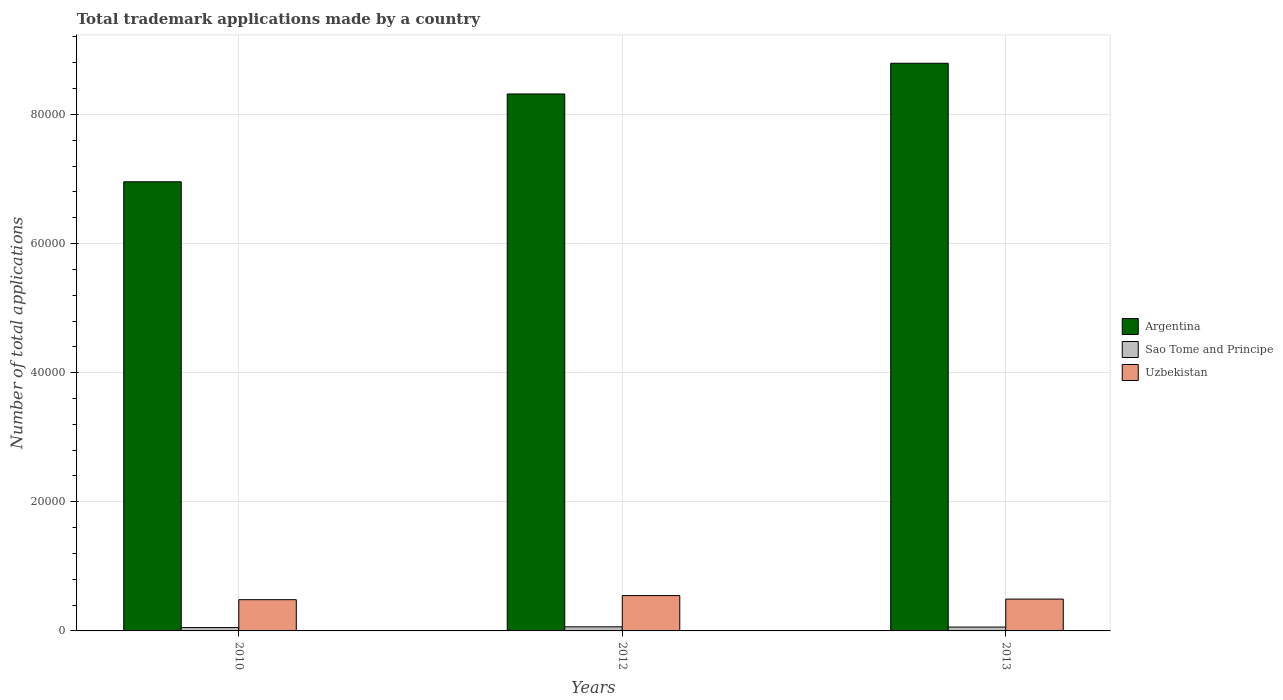How many groups of bars are there?
Make the answer very short. 3. Are the number of bars per tick equal to the number of legend labels?
Provide a succinct answer. Yes. Are the number of bars on each tick of the X-axis equal?
Your answer should be very brief. Yes. How many bars are there on the 3rd tick from the left?
Offer a terse response. 3. How many bars are there on the 3rd tick from the right?
Provide a short and direct response. 3. In how many cases, is the number of bars for a given year not equal to the number of legend labels?
Offer a terse response. 0. What is the number of applications made by in Argentina in 2012?
Offer a very short reply. 8.32e+04. Across all years, what is the maximum number of applications made by in Sao Tome and Principe?
Ensure brevity in your answer.  632. Across all years, what is the minimum number of applications made by in Sao Tome and Principe?
Provide a succinct answer. 517. In which year was the number of applications made by in Sao Tome and Principe minimum?
Offer a terse response. 2010. What is the total number of applications made by in Argentina in the graph?
Offer a terse response. 2.41e+05. What is the difference between the number of applications made by in Argentina in 2010 and that in 2013?
Your answer should be compact. -1.84e+04. What is the difference between the number of applications made by in Sao Tome and Principe in 2010 and the number of applications made by in Uzbekistan in 2012?
Offer a terse response. -4957. What is the average number of applications made by in Sao Tome and Principe per year?
Your answer should be very brief. 581.67. In the year 2010, what is the difference between the number of applications made by in Argentina and number of applications made by in Uzbekistan?
Provide a short and direct response. 6.47e+04. What is the ratio of the number of applications made by in Sao Tome and Principe in 2010 to that in 2012?
Give a very brief answer. 0.82. What is the difference between the highest and the lowest number of applications made by in Sao Tome and Principe?
Keep it short and to the point. 115. What does the 2nd bar from the left in 2013 represents?
Your response must be concise. Sao Tome and Principe. What does the 3rd bar from the right in 2013 represents?
Provide a succinct answer. Argentina. How many bars are there?
Ensure brevity in your answer.  9. Are all the bars in the graph horizontal?
Your response must be concise. No. How many years are there in the graph?
Ensure brevity in your answer.  3. What is the difference between two consecutive major ticks on the Y-axis?
Provide a succinct answer. 2.00e+04. Are the values on the major ticks of Y-axis written in scientific E-notation?
Provide a succinct answer. No. Does the graph contain any zero values?
Ensure brevity in your answer.  No. Where does the legend appear in the graph?
Provide a short and direct response. Center right. How are the legend labels stacked?
Provide a succinct answer. Vertical. What is the title of the graph?
Offer a very short reply. Total trademark applications made by a country. Does "Puerto Rico" appear as one of the legend labels in the graph?
Provide a succinct answer. No. What is the label or title of the Y-axis?
Provide a short and direct response. Number of total applications. What is the Number of total applications in Argentina in 2010?
Offer a very short reply. 6.96e+04. What is the Number of total applications of Sao Tome and Principe in 2010?
Provide a succinct answer. 517. What is the Number of total applications of Uzbekistan in 2010?
Make the answer very short. 4838. What is the Number of total applications of Argentina in 2012?
Ensure brevity in your answer.  8.32e+04. What is the Number of total applications of Sao Tome and Principe in 2012?
Offer a very short reply. 632. What is the Number of total applications in Uzbekistan in 2012?
Offer a terse response. 5474. What is the Number of total applications of Argentina in 2013?
Your answer should be compact. 8.79e+04. What is the Number of total applications of Sao Tome and Principe in 2013?
Provide a short and direct response. 596. What is the Number of total applications in Uzbekistan in 2013?
Make the answer very short. 4931. Across all years, what is the maximum Number of total applications in Argentina?
Provide a short and direct response. 8.79e+04. Across all years, what is the maximum Number of total applications of Sao Tome and Principe?
Offer a very short reply. 632. Across all years, what is the maximum Number of total applications in Uzbekistan?
Ensure brevity in your answer.  5474. Across all years, what is the minimum Number of total applications of Argentina?
Your response must be concise. 6.96e+04. Across all years, what is the minimum Number of total applications in Sao Tome and Principe?
Your response must be concise. 517. Across all years, what is the minimum Number of total applications of Uzbekistan?
Give a very brief answer. 4838. What is the total Number of total applications of Argentina in the graph?
Offer a terse response. 2.41e+05. What is the total Number of total applications of Sao Tome and Principe in the graph?
Provide a succinct answer. 1745. What is the total Number of total applications in Uzbekistan in the graph?
Keep it short and to the point. 1.52e+04. What is the difference between the Number of total applications in Argentina in 2010 and that in 2012?
Ensure brevity in your answer.  -1.36e+04. What is the difference between the Number of total applications in Sao Tome and Principe in 2010 and that in 2012?
Provide a short and direct response. -115. What is the difference between the Number of total applications in Uzbekistan in 2010 and that in 2012?
Offer a terse response. -636. What is the difference between the Number of total applications of Argentina in 2010 and that in 2013?
Make the answer very short. -1.84e+04. What is the difference between the Number of total applications in Sao Tome and Principe in 2010 and that in 2013?
Provide a short and direct response. -79. What is the difference between the Number of total applications of Uzbekistan in 2010 and that in 2013?
Ensure brevity in your answer.  -93. What is the difference between the Number of total applications of Argentina in 2012 and that in 2013?
Make the answer very short. -4758. What is the difference between the Number of total applications of Sao Tome and Principe in 2012 and that in 2013?
Your response must be concise. 36. What is the difference between the Number of total applications of Uzbekistan in 2012 and that in 2013?
Your answer should be compact. 543. What is the difference between the Number of total applications of Argentina in 2010 and the Number of total applications of Sao Tome and Principe in 2012?
Your answer should be very brief. 6.89e+04. What is the difference between the Number of total applications of Argentina in 2010 and the Number of total applications of Uzbekistan in 2012?
Offer a terse response. 6.41e+04. What is the difference between the Number of total applications in Sao Tome and Principe in 2010 and the Number of total applications in Uzbekistan in 2012?
Your answer should be very brief. -4957. What is the difference between the Number of total applications of Argentina in 2010 and the Number of total applications of Sao Tome and Principe in 2013?
Provide a short and direct response. 6.90e+04. What is the difference between the Number of total applications of Argentina in 2010 and the Number of total applications of Uzbekistan in 2013?
Give a very brief answer. 6.46e+04. What is the difference between the Number of total applications of Sao Tome and Principe in 2010 and the Number of total applications of Uzbekistan in 2013?
Your answer should be compact. -4414. What is the difference between the Number of total applications of Argentina in 2012 and the Number of total applications of Sao Tome and Principe in 2013?
Your response must be concise. 8.26e+04. What is the difference between the Number of total applications in Argentina in 2012 and the Number of total applications in Uzbekistan in 2013?
Your answer should be compact. 7.82e+04. What is the difference between the Number of total applications in Sao Tome and Principe in 2012 and the Number of total applications in Uzbekistan in 2013?
Provide a succinct answer. -4299. What is the average Number of total applications of Argentina per year?
Provide a succinct answer. 8.02e+04. What is the average Number of total applications in Sao Tome and Principe per year?
Ensure brevity in your answer.  581.67. What is the average Number of total applications in Uzbekistan per year?
Keep it short and to the point. 5081. In the year 2010, what is the difference between the Number of total applications in Argentina and Number of total applications in Sao Tome and Principe?
Keep it short and to the point. 6.90e+04. In the year 2010, what is the difference between the Number of total applications of Argentina and Number of total applications of Uzbekistan?
Offer a very short reply. 6.47e+04. In the year 2010, what is the difference between the Number of total applications in Sao Tome and Principe and Number of total applications in Uzbekistan?
Your answer should be compact. -4321. In the year 2012, what is the difference between the Number of total applications in Argentina and Number of total applications in Sao Tome and Principe?
Your response must be concise. 8.25e+04. In the year 2012, what is the difference between the Number of total applications of Argentina and Number of total applications of Uzbekistan?
Your answer should be compact. 7.77e+04. In the year 2012, what is the difference between the Number of total applications of Sao Tome and Principe and Number of total applications of Uzbekistan?
Your response must be concise. -4842. In the year 2013, what is the difference between the Number of total applications in Argentina and Number of total applications in Sao Tome and Principe?
Give a very brief answer. 8.73e+04. In the year 2013, what is the difference between the Number of total applications of Argentina and Number of total applications of Uzbekistan?
Ensure brevity in your answer.  8.30e+04. In the year 2013, what is the difference between the Number of total applications of Sao Tome and Principe and Number of total applications of Uzbekistan?
Ensure brevity in your answer.  -4335. What is the ratio of the Number of total applications of Argentina in 2010 to that in 2012?
Make the answer very short. 0.84. What is the ratio of the Number of total applications of Sao Tome and Principe in 2010 to that in 2012?
Keep it short and to the point. 0.82. What is the ratio of the Number of total applications of Uzbekistan in 2010 to that in 2012?
Your response must be concise. 0.88. What is the ratio of the Number of total applications of Argentina in 2010 to that in 2013?
Make the answer very short. 0.79. What is the ratio of the Number of total applications in Sao Tome and Principe in 2010 to that in 2013?
Make the answer very short. 0.87. What is the ratio of the Number of total applications of Uzbekistan in 2010 to that in 2013?
Offer a very short reply. 0.98. What is the ratio of the Number of total applications of Argentina in 2012 to that in 2013?
Keep it short and to the point. 0.95. What is the ratio of the Number of total applications in Sao Tome and Principe in 2012 to that in 2013?
Provide a short and direct response. 1.06. What is the ratio of the Number of total applications of Uzbekistan in 2012 to that in 2013?
Ensure brevity in your answer.  1.11. What is the difference between the highest and the second highest Number of total applications of Argentina?
Offer a terse response. 4758. What is the difference between the highest and the second highest Number of total applications of Sao Tome and Principe?
Your answer should be compact. 36. What is the difference between the highest and the second highest Number of total applications of Uzbekistan?
Keep it short and to the point. 543. What is the difference between the highest and the lowest Number of total applications of Argentina?
Make the answer very short. 1.84e+04. What is the difference between the highest and the lowest Number of total applications in Sao Tome and Principe?
Your response must be concise. 115. What is the difference between the highest and the lowest Number of total applications in Uzbekistan?
Your response must be concise. 636. 